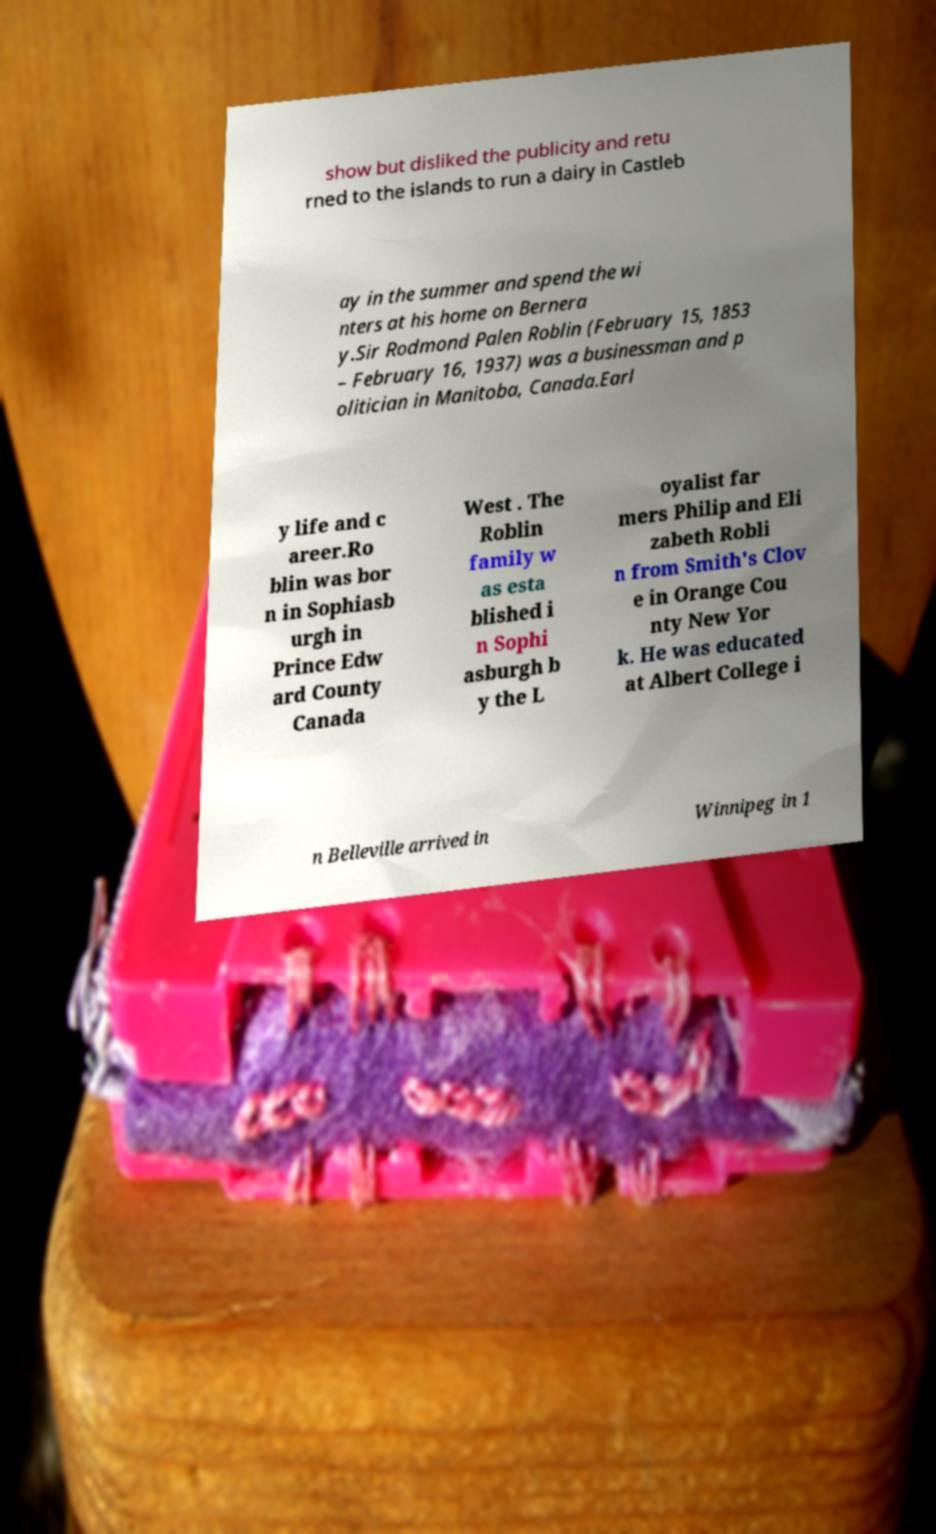For documentation purposes, I need the text within this image transcribed. Could you provide that? show but disliked the publicity and retu rned to the islands to run a dairy in Castleb ay in the summer and spend the wi nters at his home on Bernera y.Sir Rodmond Palen Roblin (February 15, 1853 – February 16, 1937) was a businessman and p olitician in Manitoba, Canada.Earl y life and c areer.Ro blin was bor n in Sophiasb urgh in Prince Edw ard County Canada West . The Roblin family w as esta blished i n Sophi asburgh b y the L oyalist far mers Philip and Eli zabeth Robli n from Smith's Clov e in Orange Cou nty New Yor k. He was educated at Albert College i n Belleville arrived in Winnipeg in 1 